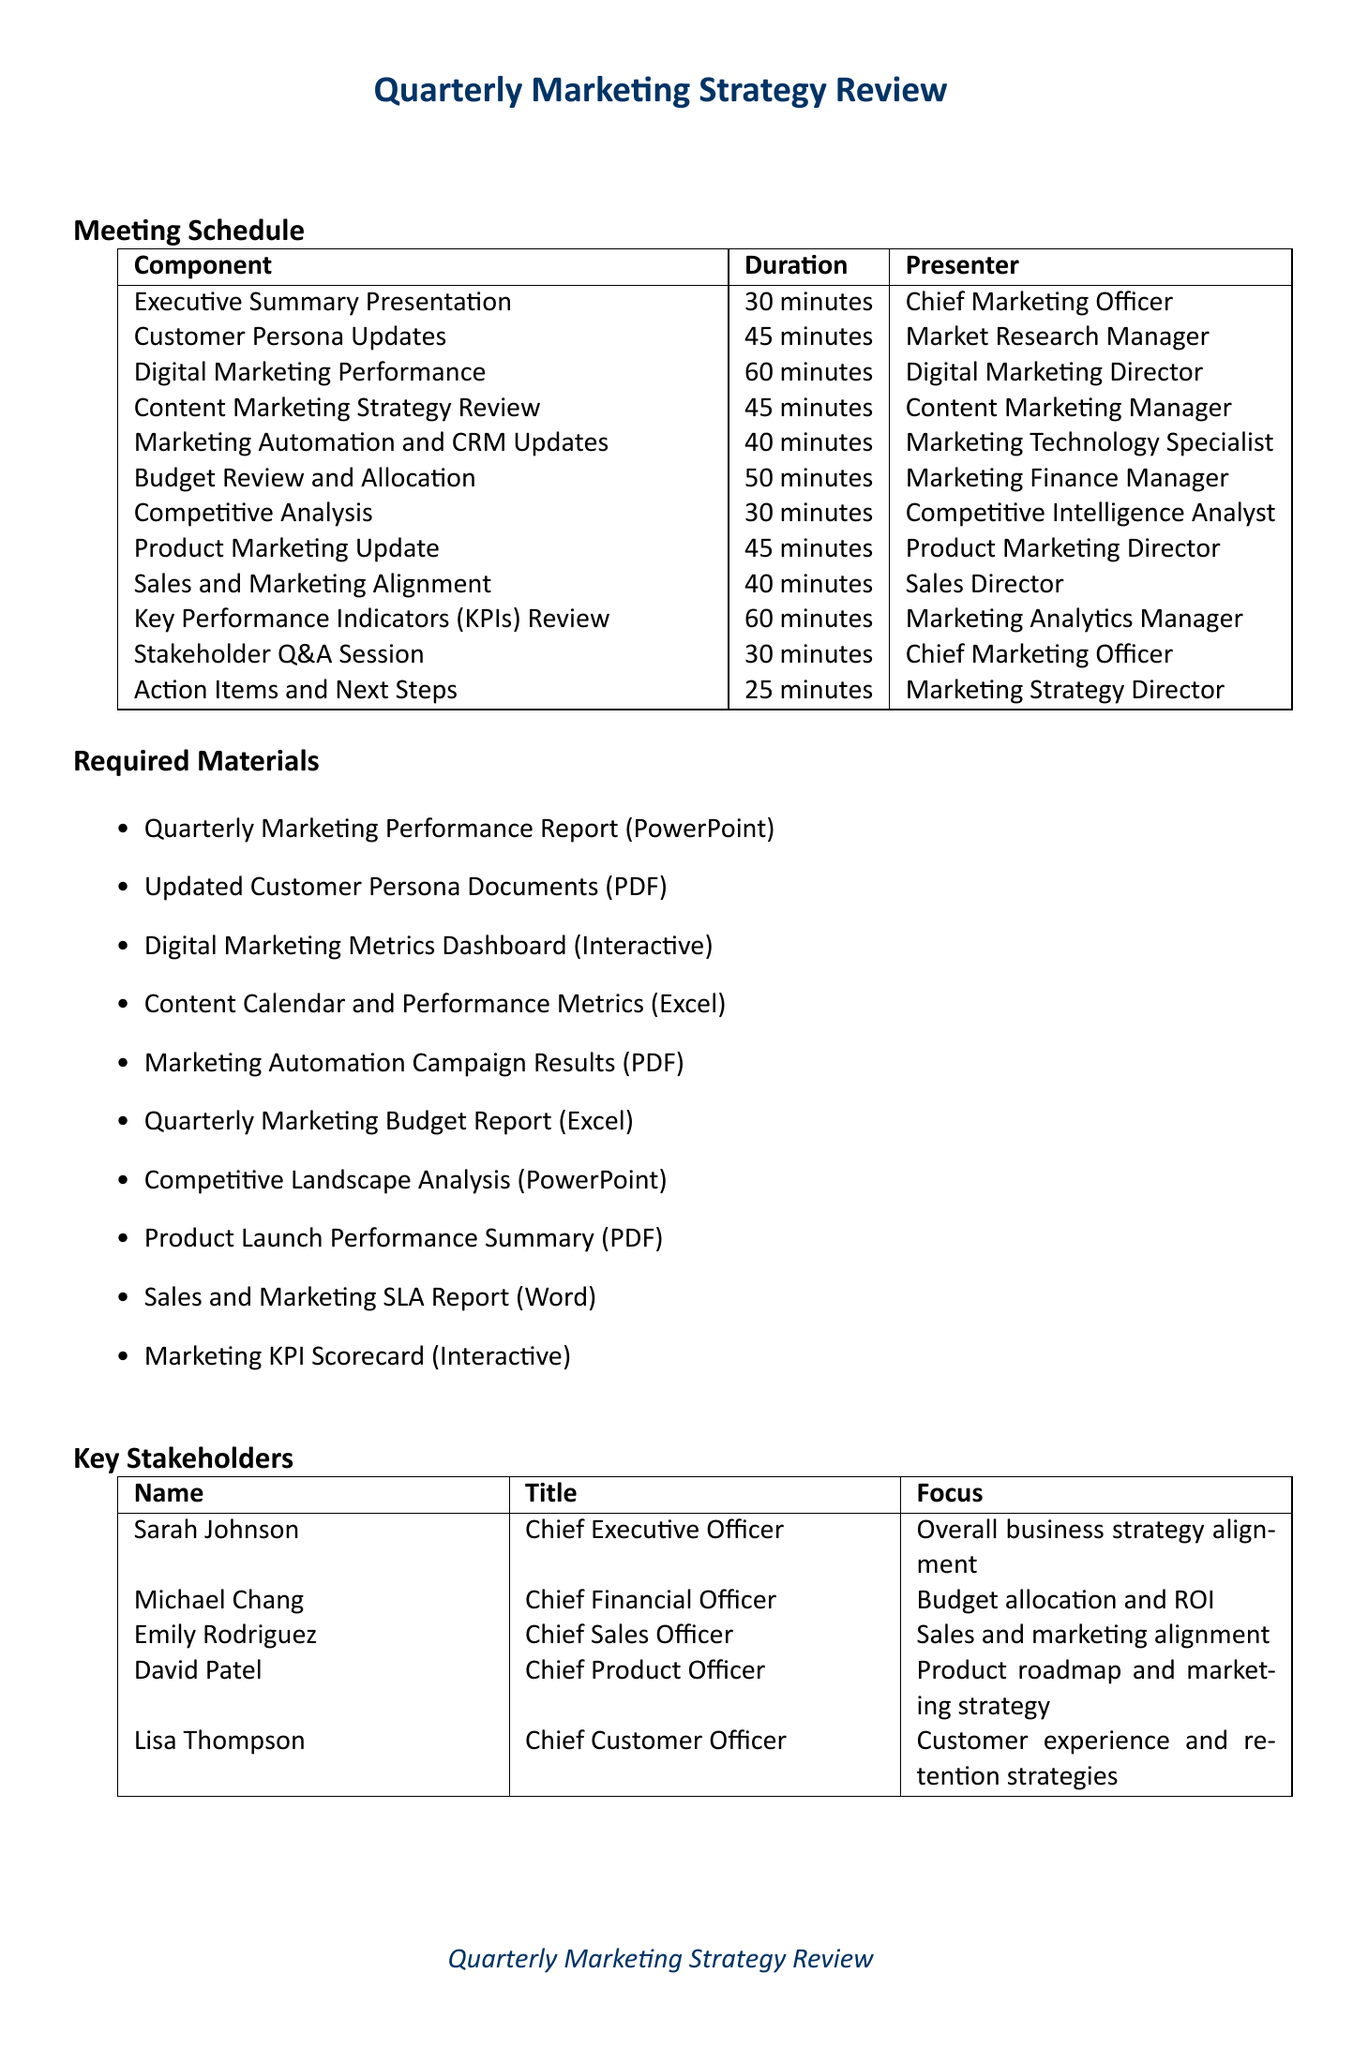what is the duration of the Executive Summary Presentation? The duration is listed in the schedule section of the document.
Answer: 30 minutes who presents the Digital Marketing Performance component? Information about presenters is provided next to each component in the schedule.
Answer: Digital Marketing Director how long is the Stakeholder Q&A Session? The duration is specified in the meeting schedule within the document.
Answer: 30 minutes what is one of the required materials for the meeting? The required materials are listed in a bullet-point format in the document.
Answer: Quarterly Marketing Performance Report which title is associated with Sarah Johnson? The title of each key stakeholder is specified in the schedule's key stakeholders section.
Answer: Chief Executive Officer how many minutes are allocated for the Budget Review and Allocation? This information is found in the meeting schedule section of the document.
Answer: 50 minutes what is the main focus of Lisa Thompson? The focus for each key stakeholder is stated in the key stakeholders section.
Answer: Customer experience and retention strategies who will facilitate the Action Items and Next Steps? The facilitator for each segment is mentioned in the meeting schedule.
Answer: Marketing Strategy Director what is the total duration of all presentations? The total duration can be calculated by adding up the durations listed for each component.
Answer: 480 minutes 